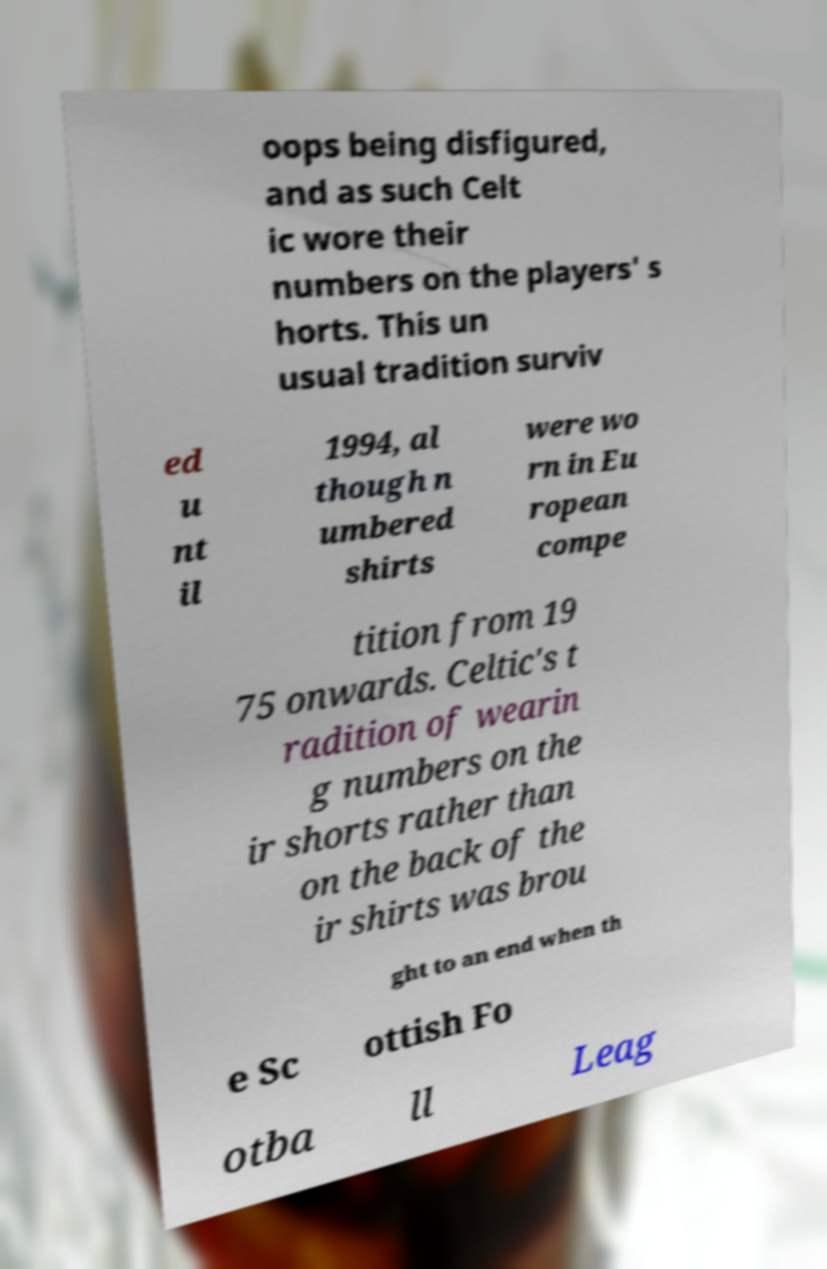Can you read and provide the text displayed in the image?This photo seems to have some interesting text. Can you extract and type it out for me? oops being disfigured, and as such Celt ic wore their numbers on the players' s horts. This un usual tradition surviv ed u nt il 1994, al though n umbered shirts were wo rn in Eu ropean compe tition from 19 75 onwards. Celtic's t radition of wearin g numbers on the ir shorts rather than on the back of the ir shirts was brou ght to an end when th e Sc ottish Fo otba ll Leag 